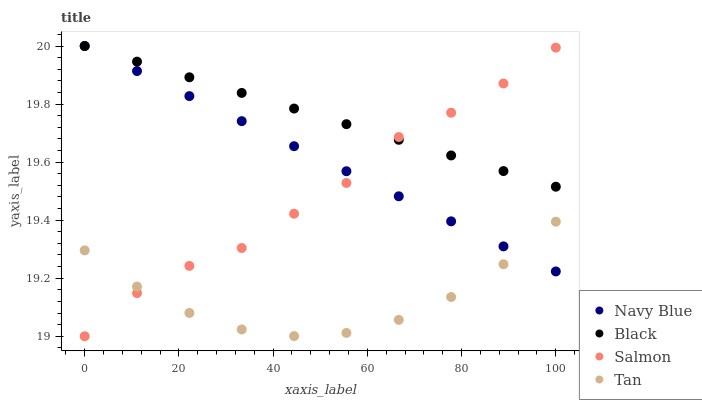Does Tan have the minimum area under the curve?
Answer yes or no. Yes. Does Black have the maximum area under the curve?
Answer yes or no. Yes. Does Black have the minimum area under the curve?
Answer yes or no. No. Does Tan have the maximum area under the curve?
Answer yes or no. No. Is Navy Blue the smoothest?
Answer yes or no. Yes. Is Salmon the roughest?
Answer yes or no. Yes. Is Tan the smoothest?
Answer yes or no. No. Is Tan the roughest?
Answer yes or no. No. Does Salmon have the lowest value?
Answer yes or no. Yes. Does Tan have the lowest value?
Answer yes or no. No. Does Black have the highest value?
Answer yes or no. Yes. Does Tan have the highest value?
Answer yes or no. No. Is Tan less than Black?
Answer yes or no. Yes. Is Black greater than Tan?
Answer yes or no. Yes. Does Tan intersect Navy Blue?
Answer yes or no. Yes. Is Tan less than Navy Blue?
Answer yes or no. No. Is Tan greater than Navy Blue?
Answer yes or no. No. Does Tan intersect Black?
Answer yes or no. No. 